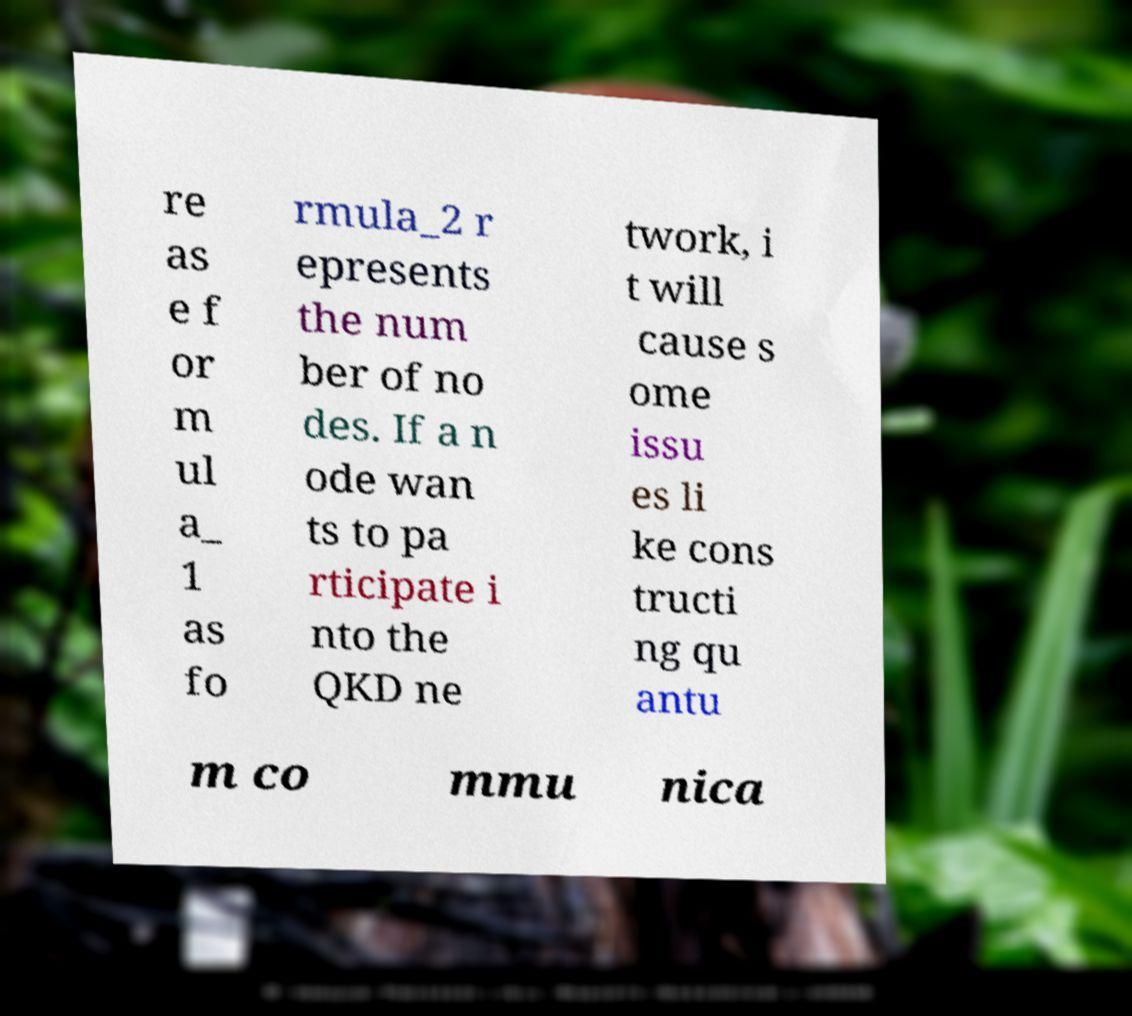Could you extract and type out the text from this image? re as e f or m ul a_ 1 as fo rmula_2 r epresents the num ber of no des. If a n ode wan ts to pa rticipate i nto the QKD ne twork, i t will cause s ome issu es li ke cons tructi ng qu antu m co mmu nica 